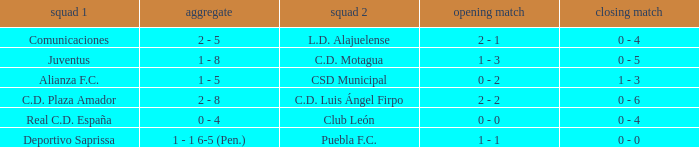What is the 1st leg where Team 1 is C.D. Plaza Amador? 2 - 2. 